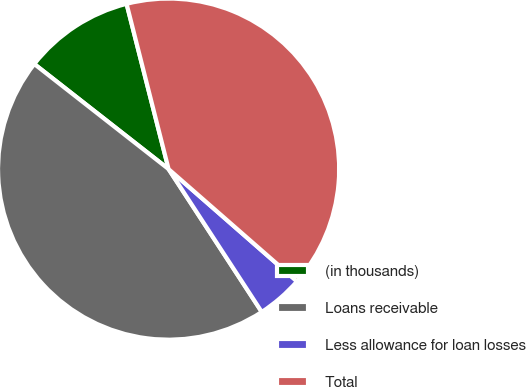Convert chart. <chart><loc_0><loc_0><loc_500><loc_500><pie_chart><fcel>(in thousands)<fcel>Loans receivable<fcel>Less allowance for loan losses<fcel>Total<nl><fcel>10.47%<fcel>44.77%<fcel>4.37%<fcel>40.4%<nl></chart> 